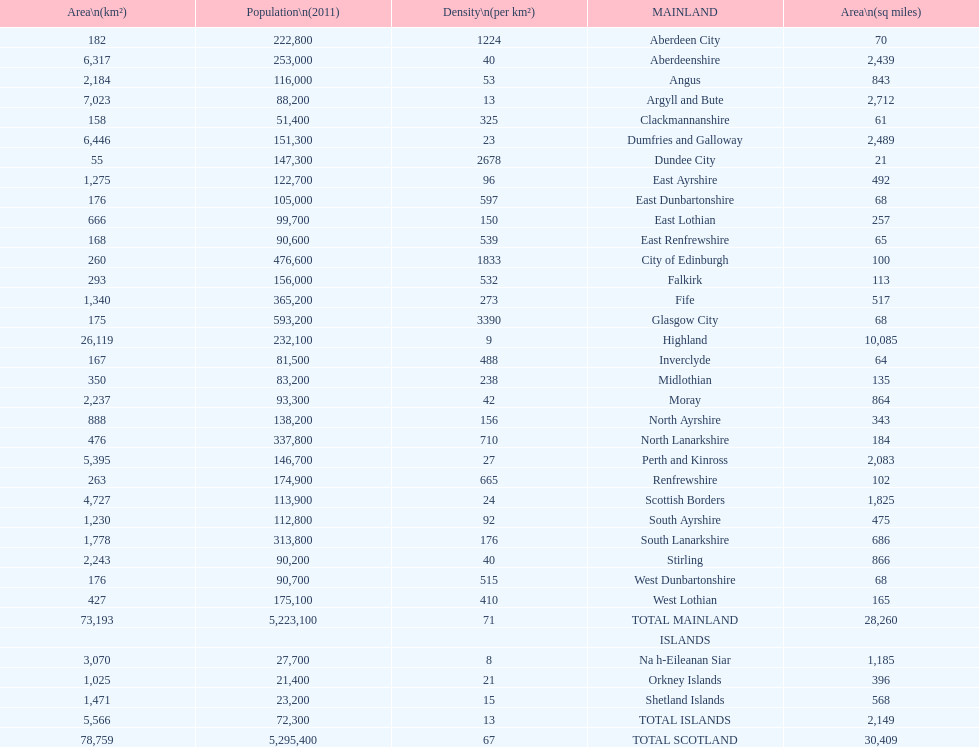Which mainland has the least population? Clackmannanshire. 